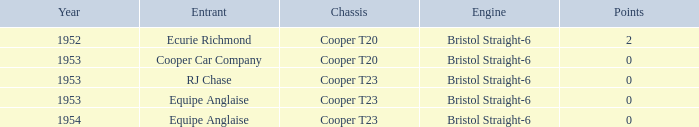Which participant was in attendance before 1953? Ecurie Richmond. 